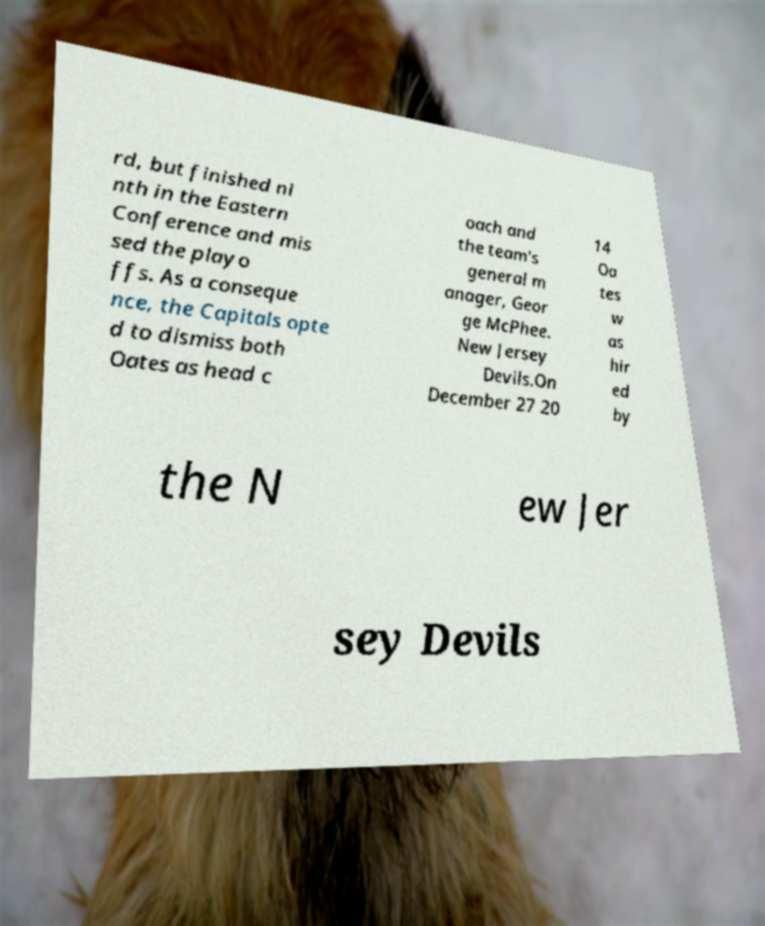What messages or text are displayed in this image? I need them in a readable, typed format. rd, but finished ni nth in the Eastern Conference and mis sed the playo ffs. As a conseque nce, the Capitals opte d to dismiss both Oates as head c oach and the team's general m anager, Geor ge McPhee. New Jersey Devils.On December 27 20 14 Oa tes w as hir ed by the N ew Jer sey Devils 